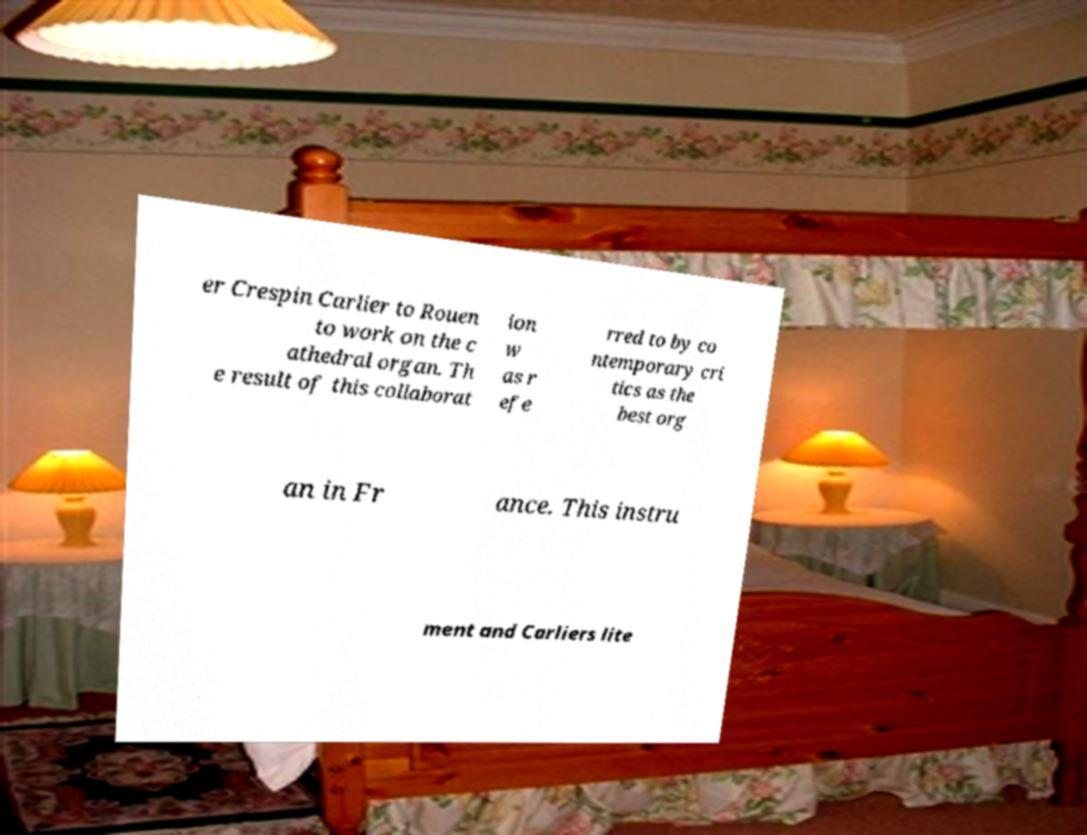Can you accurately transcribe the text from the provided image for me? er Crespin Carlier to Rouen to work on the c athedral organ. Th e result of this collaborat ion w as r efe rred to by co ntemporary cri tics as the best org an in Fr ance. This instru ment and Carliers lite 